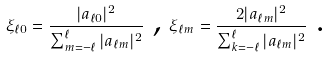Convert formula to latex. <formula><loc_0><loc_0><loc_500><loc_500>\xi _ { \ell 0 } = \frac { | a _ { \ell 0 } | ^ { 2 } } { \sum _ { m = - \ell } ^ { \ell } | a _ { \ell m } | ^ { 2 } } \text { , } \xi _ { \ell m } = \frac { 2 | a _ { \ell m } | ^ { 2 } } { \sum _ { k = - \ell } ^ { \ell } | a _ { \ell m } | ^ { 2 } } \text { .}</formula> 